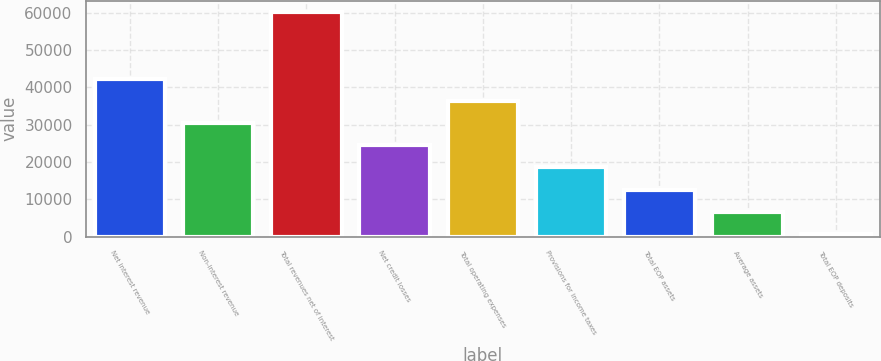Convert chart to OTSL. <chart><loc_0><loc_0><loc_500><loc_500><bar_chart><fcel>Net interest revenue<fcel>Non-interest revenue<fcel>Total revenues net of interest<fcel>Net credit losses<fcel>Total operating expenses<fcel>Provisions for income taxes<fcel>Total EOP assets<fcel>Average assets<fcel>Total EOP deposits<nl><fcel>42363.5<fcel>30468.5<fcel>60206<fcel>24521<fcel>36416<fcel>18573.5<fcel>12626<fcel>6678.5<fcel>731<nl></chart> 